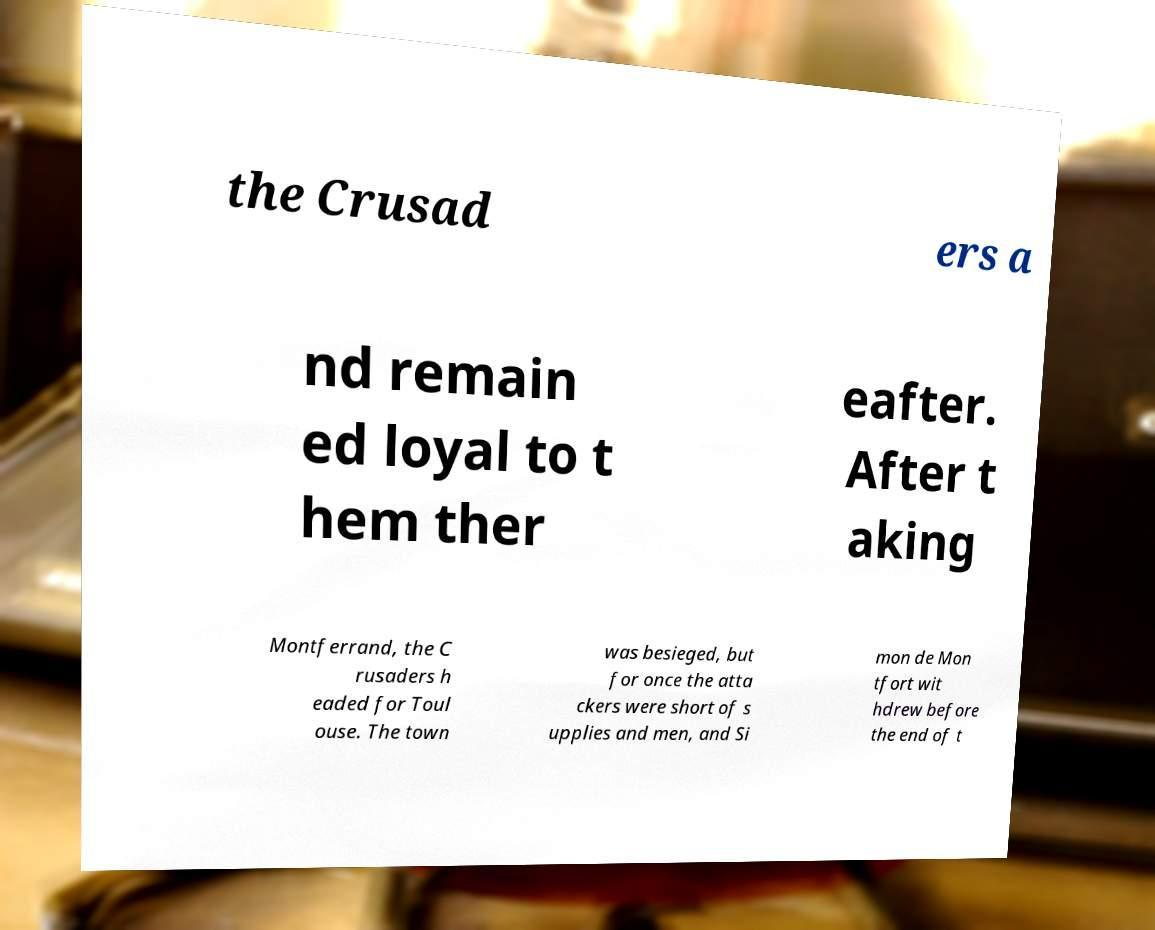For documentation purposes, I need the text within this image transcribed. Could you provide that? the Crusad ers a nd remain ed loyal to t hem ther eafter. After t aking Montferrand, the C rusaders h eaded for Toul ouse. The town was besieged, but for once the atta ckers were short of s upplies and men, and Si mon de Mon tfort wit hdrew before the end of t 